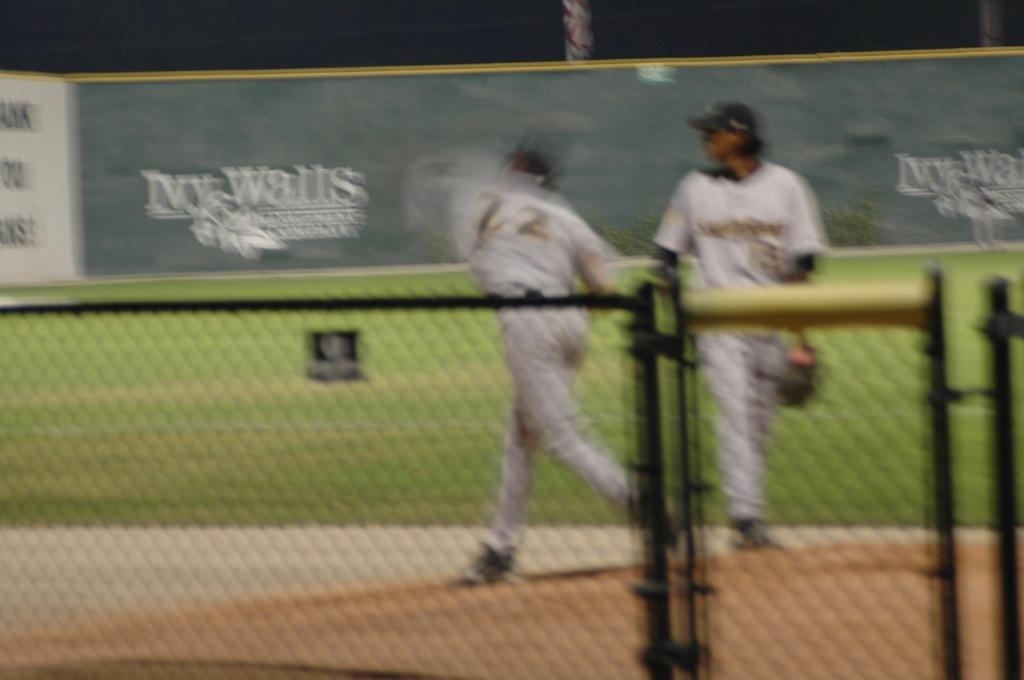Describe this image in one or two sentences. In this image we can see two persons. In the foreground we can see a fencing. Behind the persons we can see an advertising board and grass. On the boards we can see some text. 